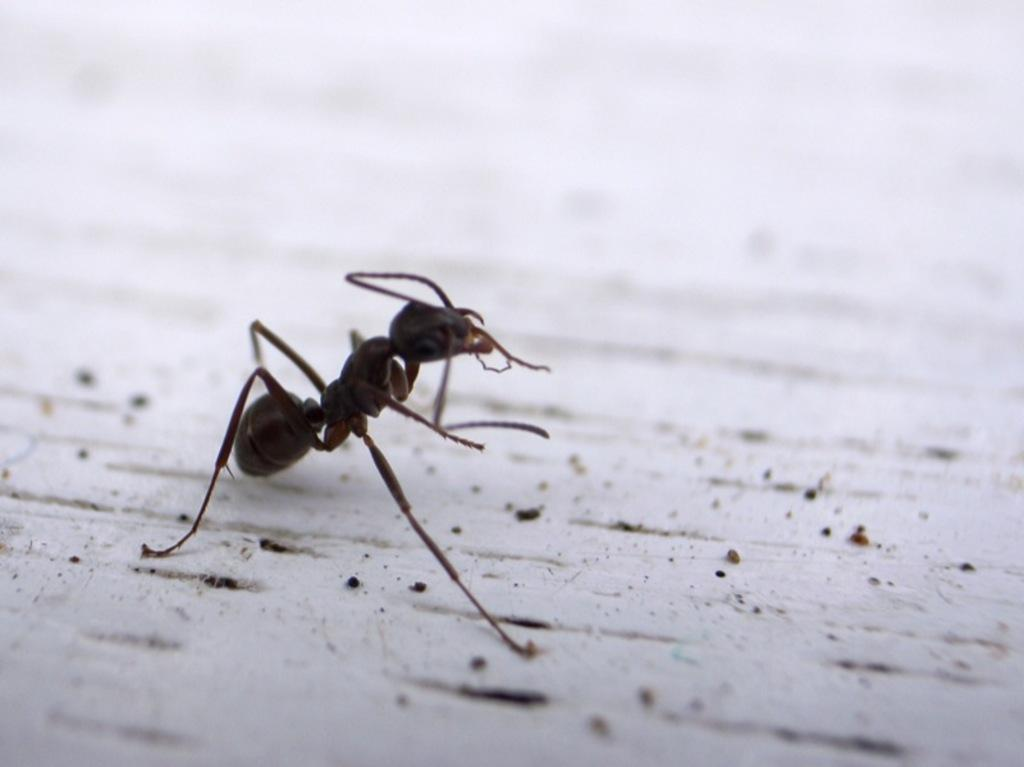What is the main subject of the image? There is an ant in the image. Can you describe the background of the image? The background of the image is blurred. Where is the dock located in the image? There is no dock present in the image; it only features an ant and a blurred background. Who is the friend of the ant in the image? There are no other creatures or friends present in the image, only the ant. 